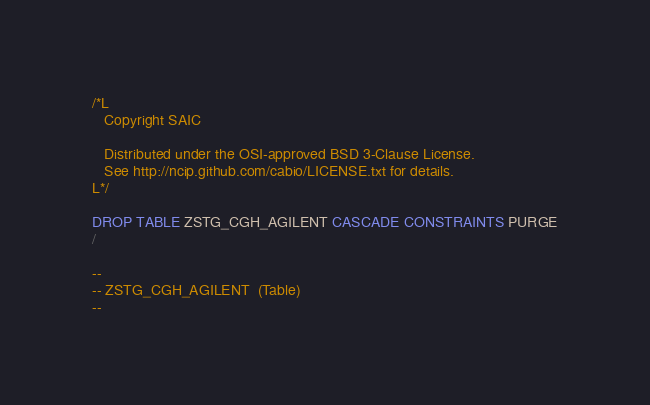<code> <loc_0><loc_0><loc_500><loc_500><_SQL_>/*L
   Copyright SAIC

   Distributed under the OSI-approved BSD 3-Clause License.
   See http://ncip.github.com/cabio/LICENSE.txt for details.
L*/

DROP TABLE ZSTG_CGH_AGILENT CASCADE CONSTRAINTS PURGE
/

--
-- ZSTG_CGH_AGILENT  (Table) 
--</code> 